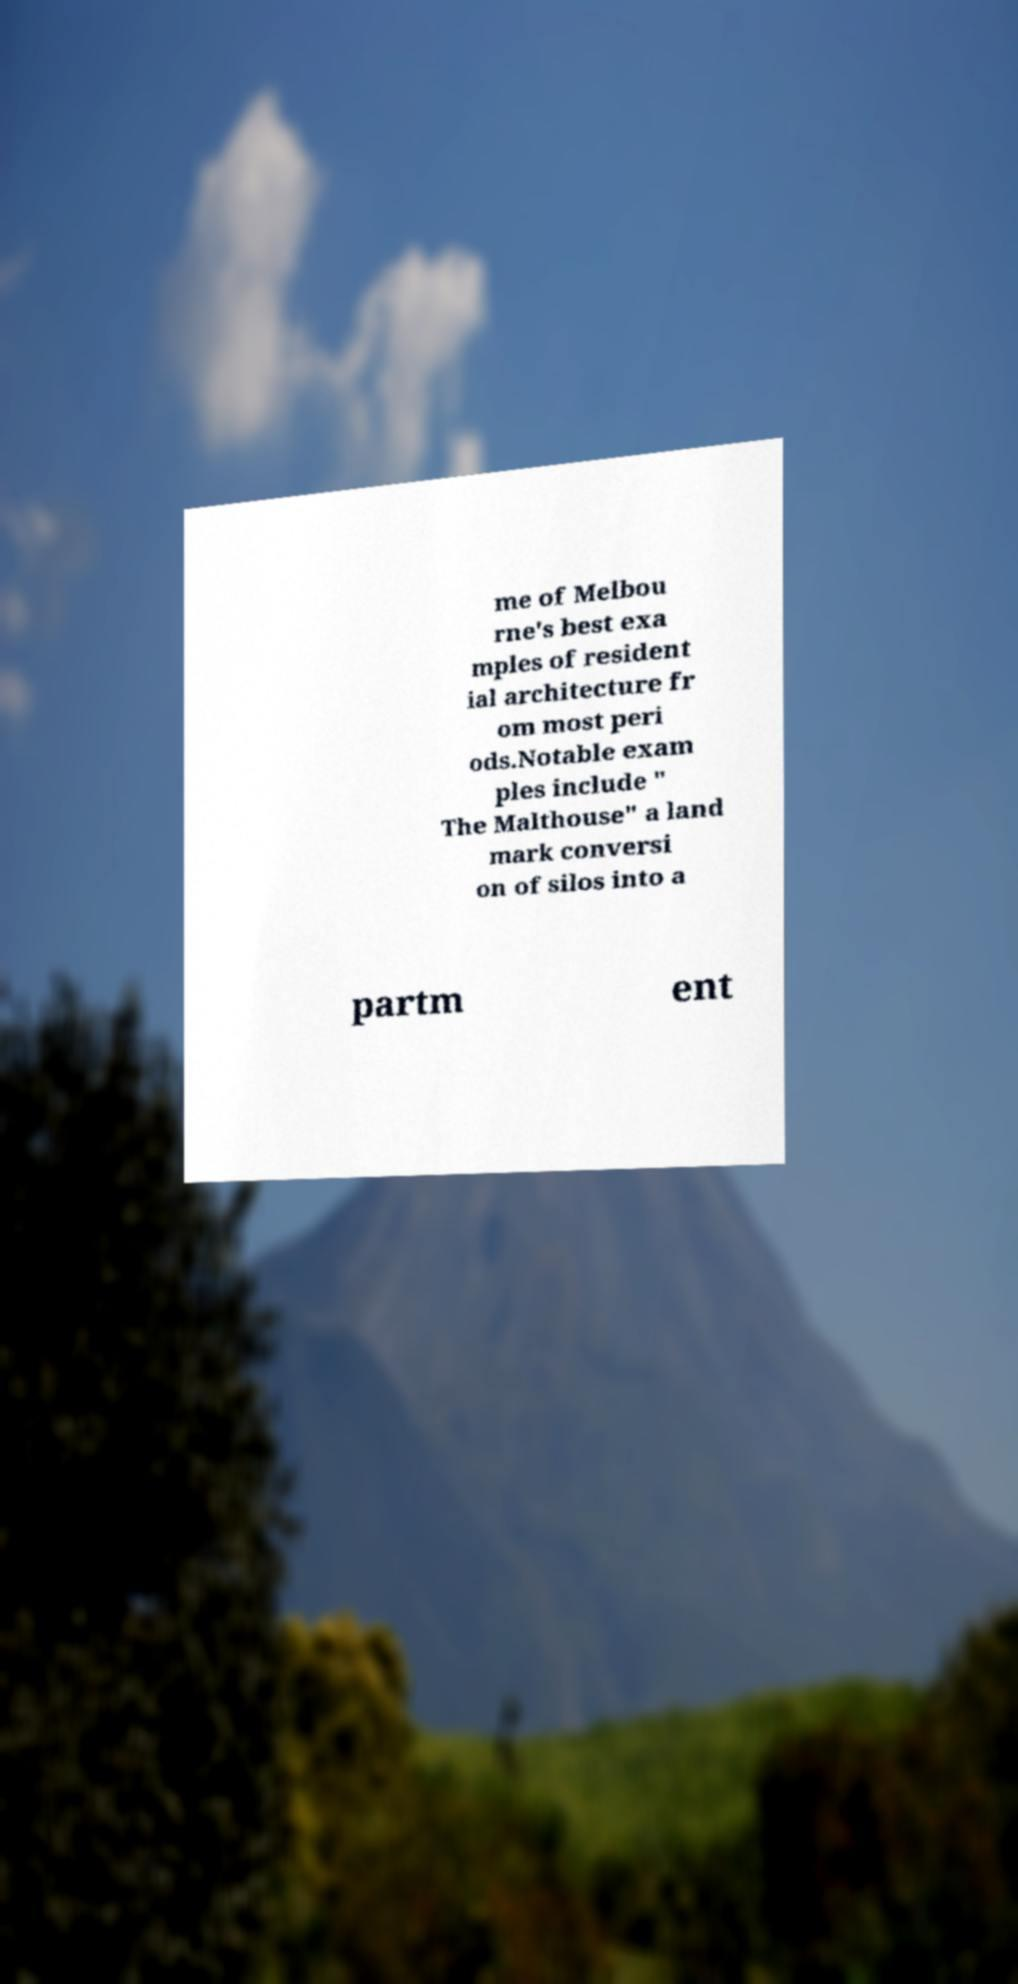Please identify and transcribe the text found in this image. me of Melbou rne's best exa mples of resident ial architecture fr om most peri ods.Notable exam ples include " The Malthouse" a land mark conversi on of silos into a partm ent 